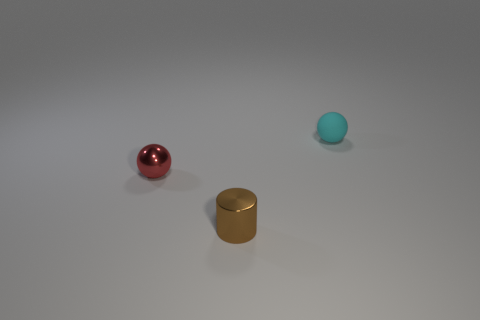Add 3 metallic cylinders. How many objects exist? 6 Subtract all balls. How many objects are left? 1 Subtract all tiny purple metallic spheres. Subtract all small red objects. How many objects are left? 2 Add 1 small cylinders. How many small cylinders are left? 2 Add 2 shiny things. How many shiny things exist? 4 Subtract 0 green blocks. How many objects are left? 3 